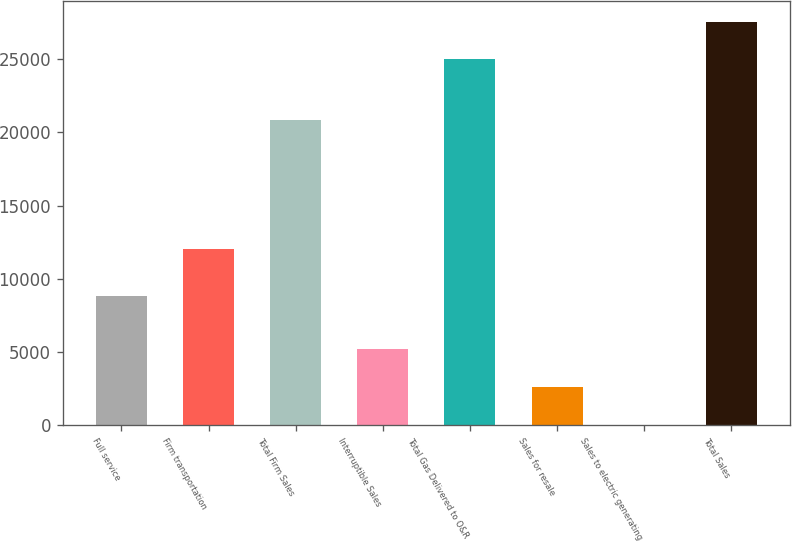<chart> <loc_0><loc_0><loc_500><loc_500><bar_chart><fcel>Full service<fcel>Firm transportation<fcel>Total Firm Sales<fcel>Interruptible Sales<fcel>Total Gas Delivered to O&R<fcel>Sales for resale<fcel>Sales to electric generating<fcel>Total Sales<nl><fcel>8808<fcel>12062<fcel>20870<fcel>5193.6<fcel>24988<fcel>2606.3<fcel>19<fcel>27575.3<nl></chart> 